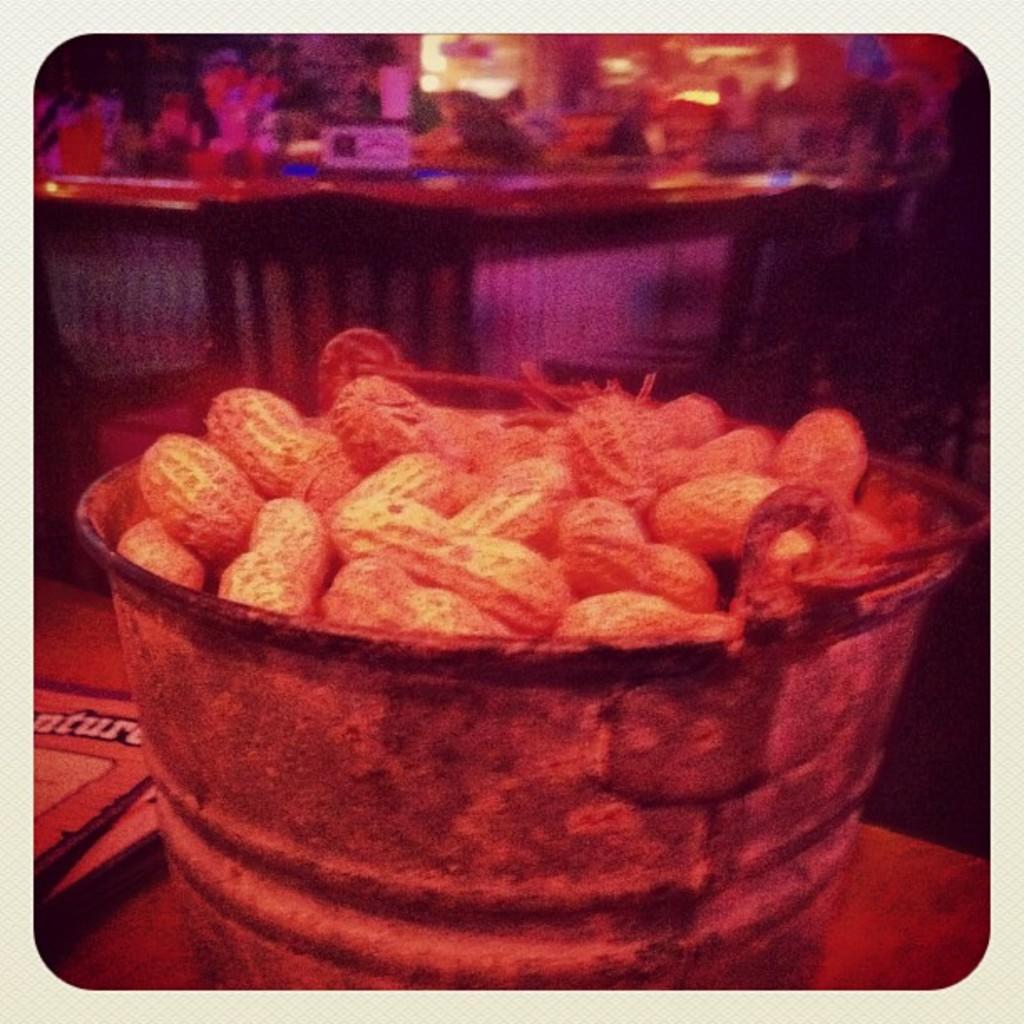Describe this image in one or two sentences. In the center of the image we can see groundnuts in a bucket placed on the table. In the background we can see objects on table and chairs. 